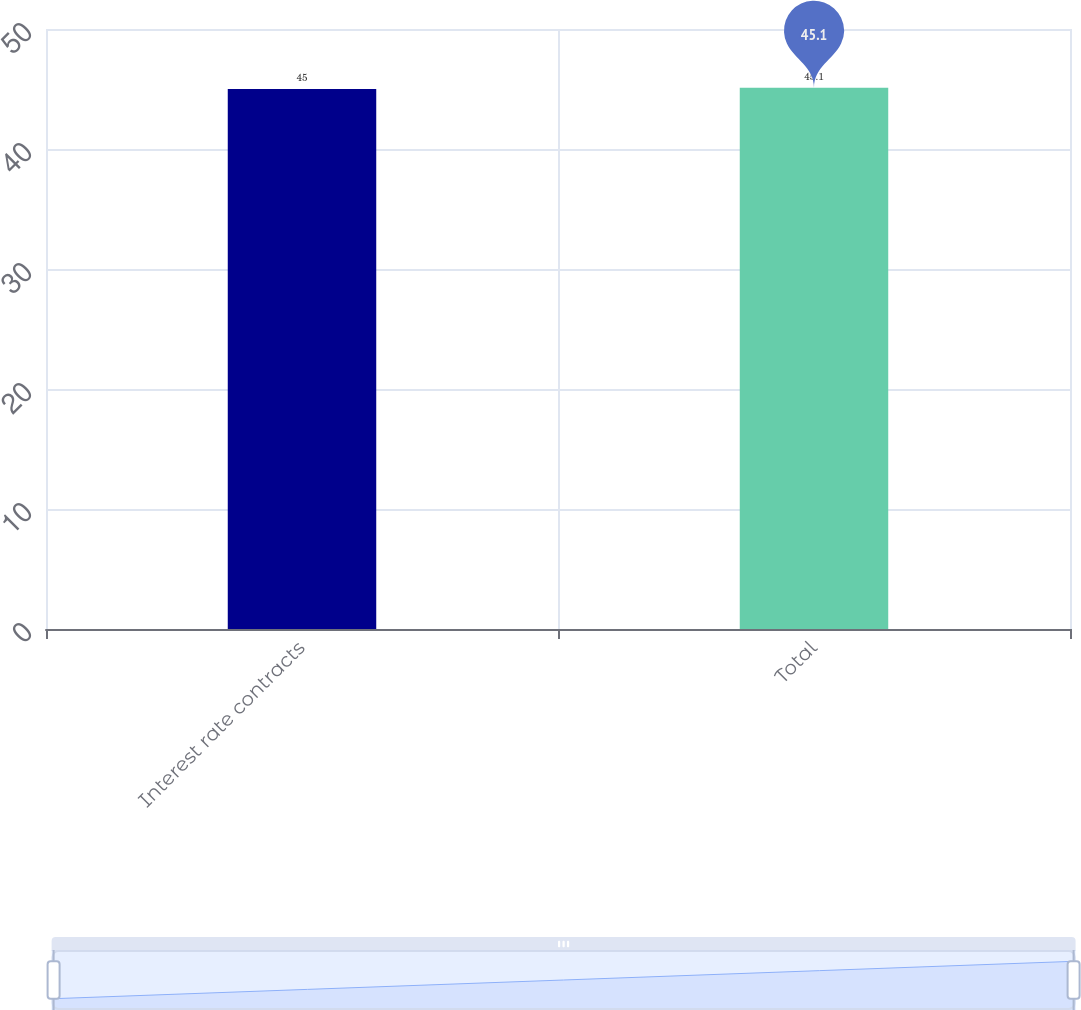Convert chart to OTSL. <chart><loc_0><loc_0><loc_500><loc_500><bar_chart><fcel>Interest rate contracts<fcel>Total<nl><fcel>45<fcel>45.1<nl></chart> 